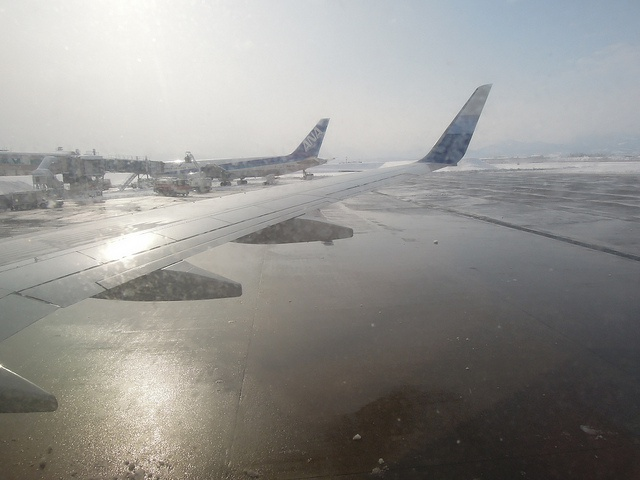Describe the objects in this image and their specific colors. I can see airplane in lightgray, darkgray, and gray tones and airplane in lightgray and gray tones in this image. 